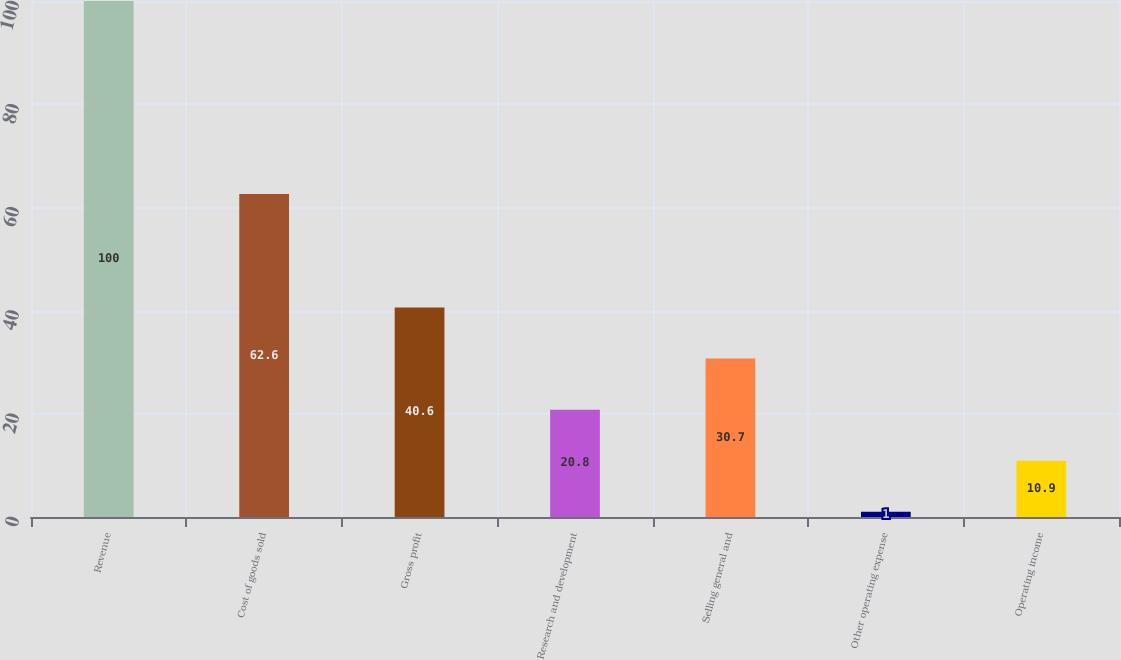Convert chart to OTSL. <chart><loc_0><loc_0><loc_500><loc_500><bar_chart><fcel>Revenue<fcel>Cost of goods sold<fcel>Gross profit<fcel>Research and development<fcel>Selling general and<fcel>Other operating expense<fcel>Operating income<nl><fcel>100<fcel>62.6<fcel>40.6<fcel>20.8<fcel>30.7<fcel>1<fcel>10.9<nl></chart> 